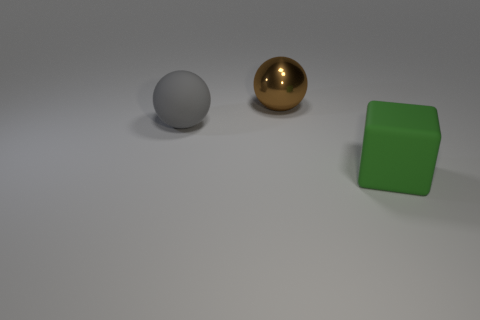Add 3 big green cubes. How many objects exist? 6 Subtract all blocks. How many objects are left? 2 Subtract all small red metallic spheres. Subtract all balls. How many objects are left? 1 Add 2 large cubes. How many large cubes are left? 3 Add 3 yellow metal cylinders. How many yellow metal cylinders exist? 3 Subtract 0 purple spheres. How many objects are left? 3 